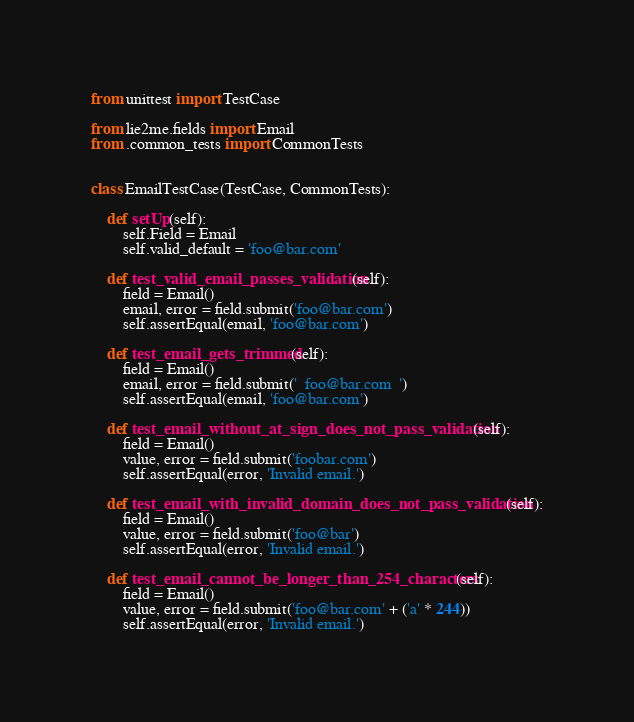Convert code to text. <code><loc_0><loc_0><loc_500><loc_500><_Python_>from unittest import TestCase

from lie2me.fields import Email
from .common_tests import CommonTests


class EmailTestCase(TestCase, CommonTests):

    def setUp(self):
        self.Field = Email
        self.valid_default = 'foo@bar.com'

    def test_valid_email_passes_validation(self):
        field = Email()
        email, error = field.submit('foo@bar.com')
        self.assertEqual(email, 'foo@bar.com')

    def test_email_gets_trimmed(self):
        field = Email()
        email, error = field.submit('  foo@bar.com  ')
        self.assertEqual(email, 'foo@bar.com')

    def test_email_without_at_sign_does_not_pass_validation(self):
        field = Email()
        value, error = field.submit('foobar.com')
        self.assertEqual(error, 'Invalid email.')

    def test_email_with_invalid_domain_does_not_pass_validation(self):
        field = Email()
        value, error = field.submit('foo@bar')
        self.assertEqual(error, 'Invalid email.')

    def test_email_cannot_be_longer_than_254_characters(self):
        field = Email()
        value, error = field.submit('foo@bar.com' + ('a' * 244))
        self.assertEqual(error, 'Invalid email.')
</code> 